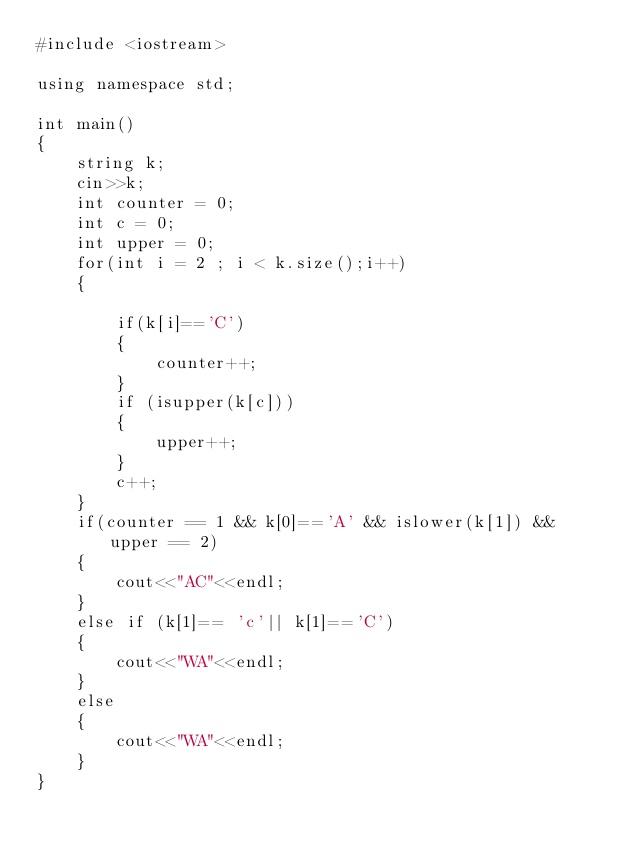Convert code to text. <code><loc_0><loc_0><loc_500><loc_500><_C++_>#include <iostream>

using namespace std;

int main()
{
    string k;
    cin>>k;
    int counter = 0;
    int c = 0;
    int upper = 0;
    for(int i = 2 ; i < k.size();i++)
    {

        if(k[i]=='C')
        {
            counter++;
        }
        if (isupper(k[c]))
        {
            upper++;
        }
        c++;
    }
    if(counter == 1 && k[0]=='A' && islower(k[1]) && upper == 2)
    {
        cout<<"AC"<<endl;
    }
    else if (k[1]== 'c'|| k[1]=='C')
    {
        cout<<"WA"<<endl;
    }
    else
    {
        cout<<"WA"<<endl;
    }
}
</code> 